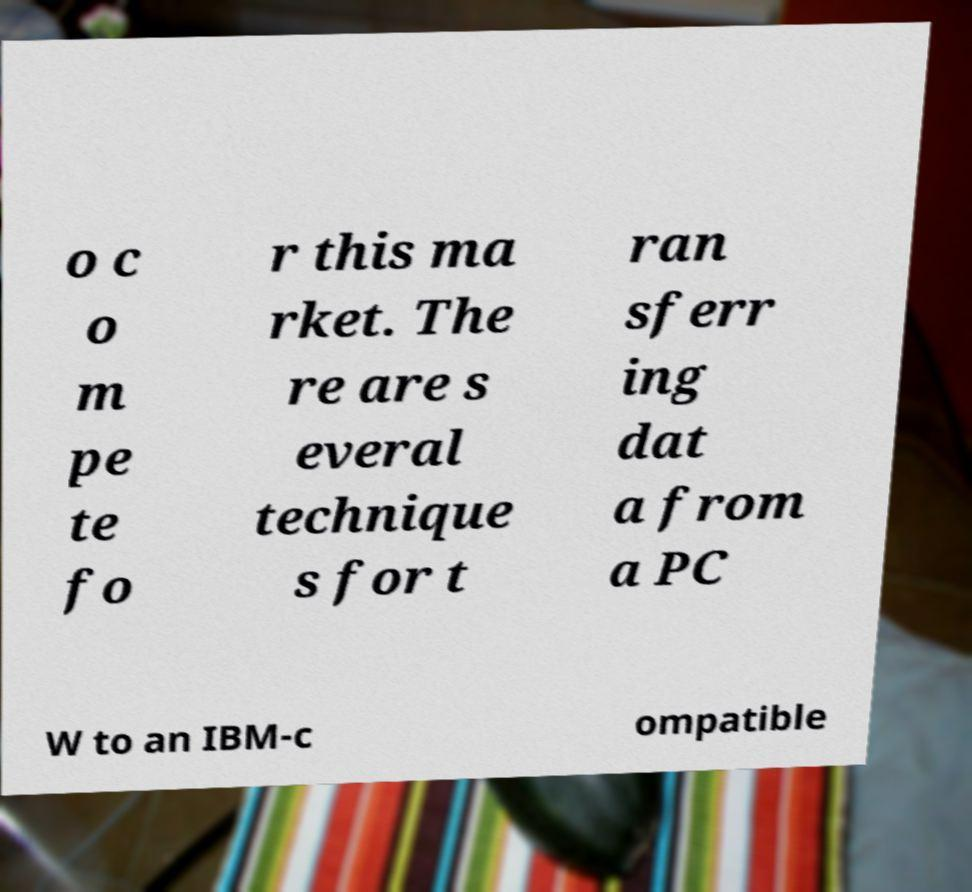Could you assist in decoding the text presented in this image and type it out clearly? o c o m pe te fo r this ma rket. The re are s everal technique s for t ran sferr ing dat a from a PC W to an IBM-c ompatible 